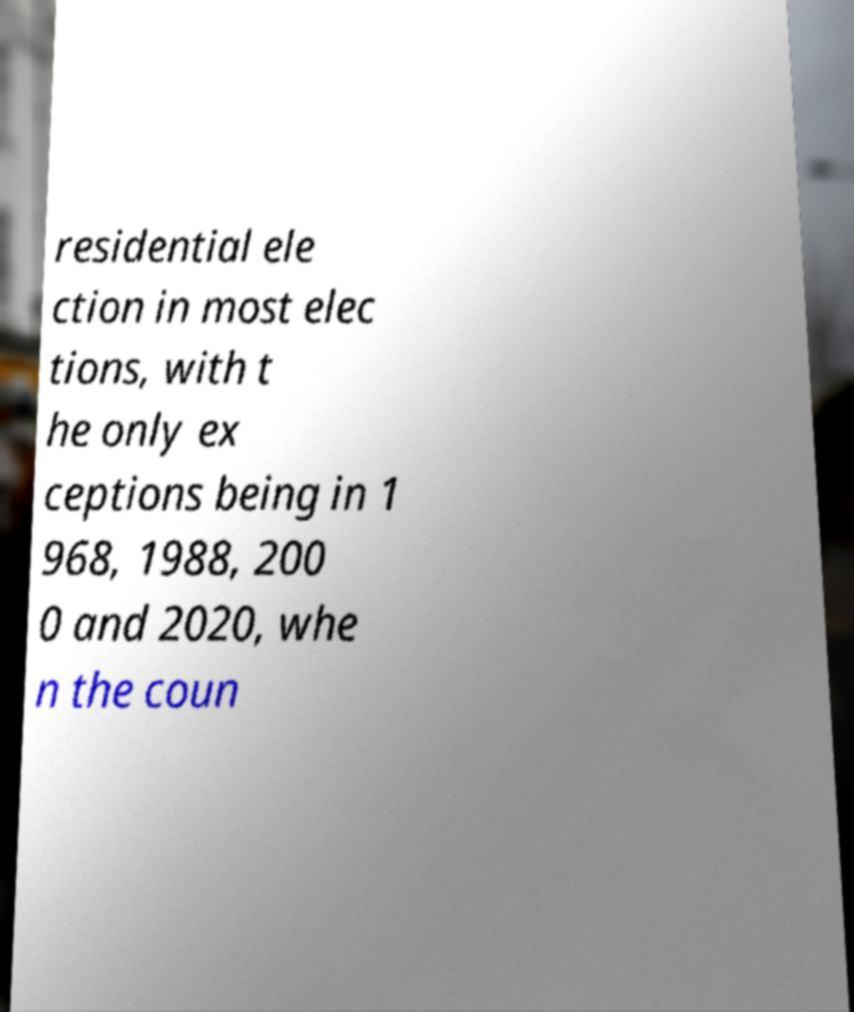Can you read and provide the text displayed in the image?This photo seems to have some interesting text. Can you extract and type it out for me? residential ele ction in most elec tions, with t he only ex ceptions being in 1 968, 1988, 200 0 and 2020, whe n the coun 